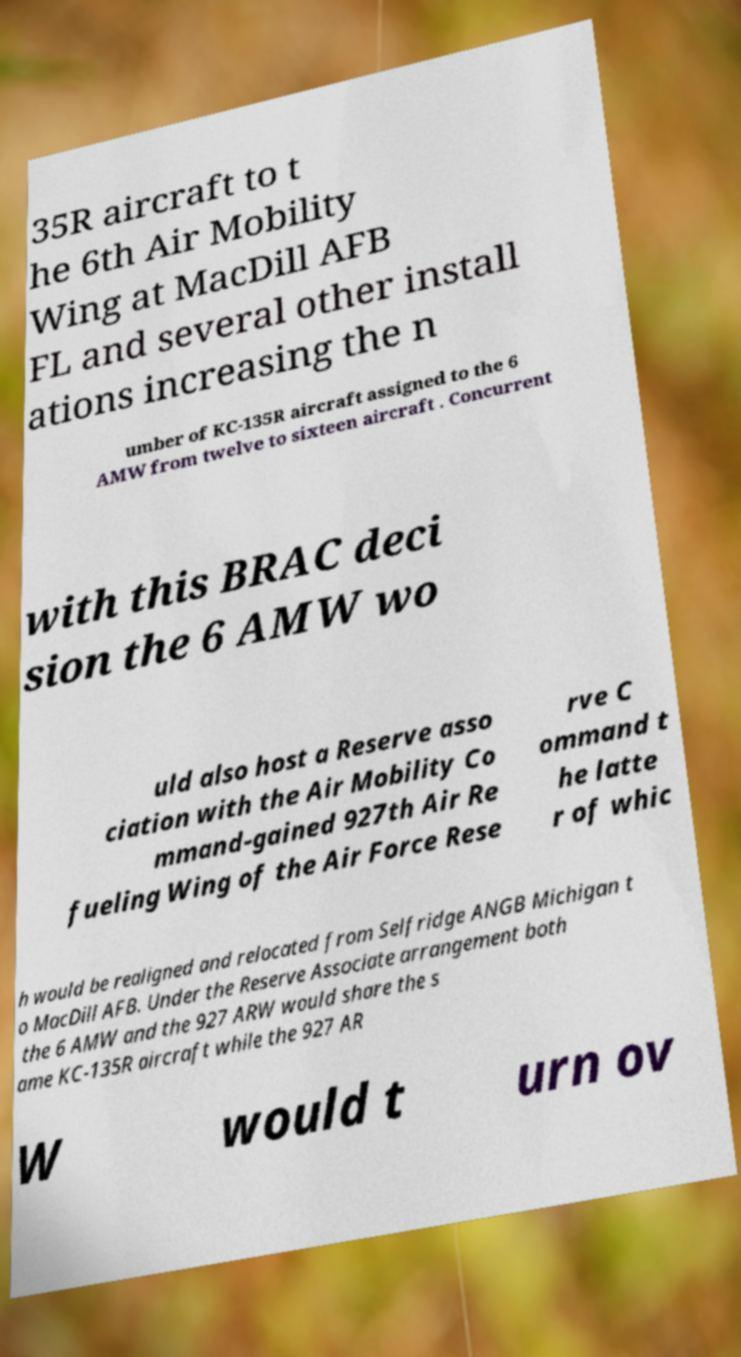Could you extract and type out the text from this image? 35R aircraft to t he 6th Air Mobility Wing at MacDill AFB FL and several other install ations increasing the n umber of KC-135R aircraft assigned to the 6 AMW from twelve to sixteen aircraft . Concurrent with this BRAC deci sion the 6 AMW wo uld also host a Reserve asso ciation with the Air Mobility Co mmand-gained 927th Air Re fueling Wing of the Air Force Rese rve C ommand t he latte r of whic h would be realigned and relocated from Selfridge ANGB Michigan t o MacDill AFB. Under the Reserve Associate arrangement both the 6 AMW and the 927 ARW would share the s ame KC-135R aircraft while the 927 AR W would t urn ov 